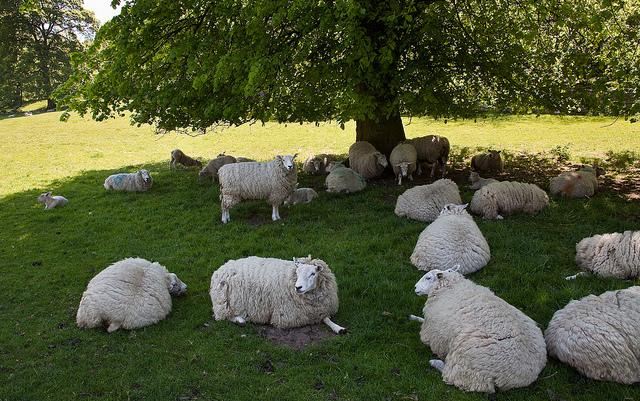How many sheep are here?
Concise answer only. 22. What are the sheep doing?
Be succinct. Resting. Are more sheep laying down or standing up?
Be succinct. Laying down. 